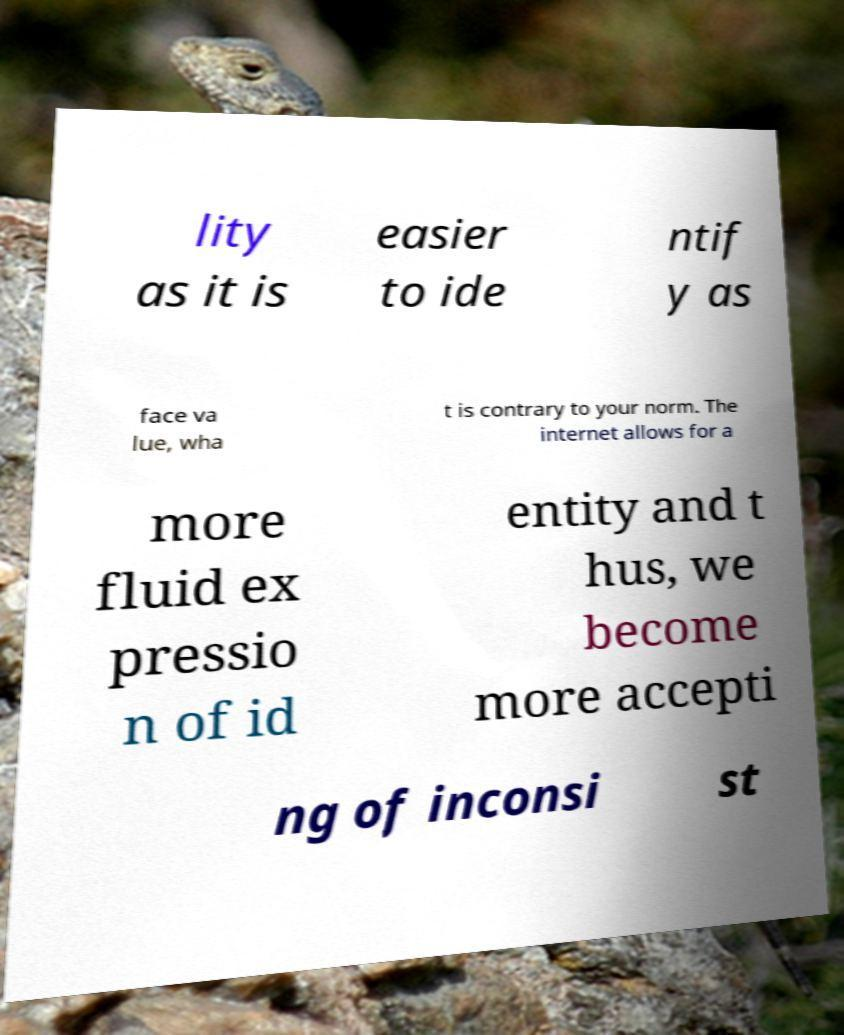I need the written content from this picture converted into text. Can you do that? lity as it is easier to ide ntif y as face va lue, wha t is contrary to your norm. The internet allows for a more fluid ex pressio n of id entity and t hus, we become more accepti ng of inconsi st 